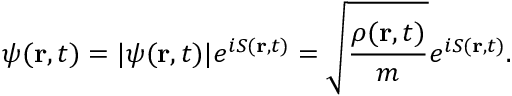Convert formula to latex. <formula><loc_0><loc_0><loc_500><loc_500>\psi ( r , t ) = | \psi ( r , t ) | e ^ { i S ( r , t ) } = \sqrt { \frac { \rho ( r , t ) } { m } } e ^ { i S ( r , t ) } .</formula> 